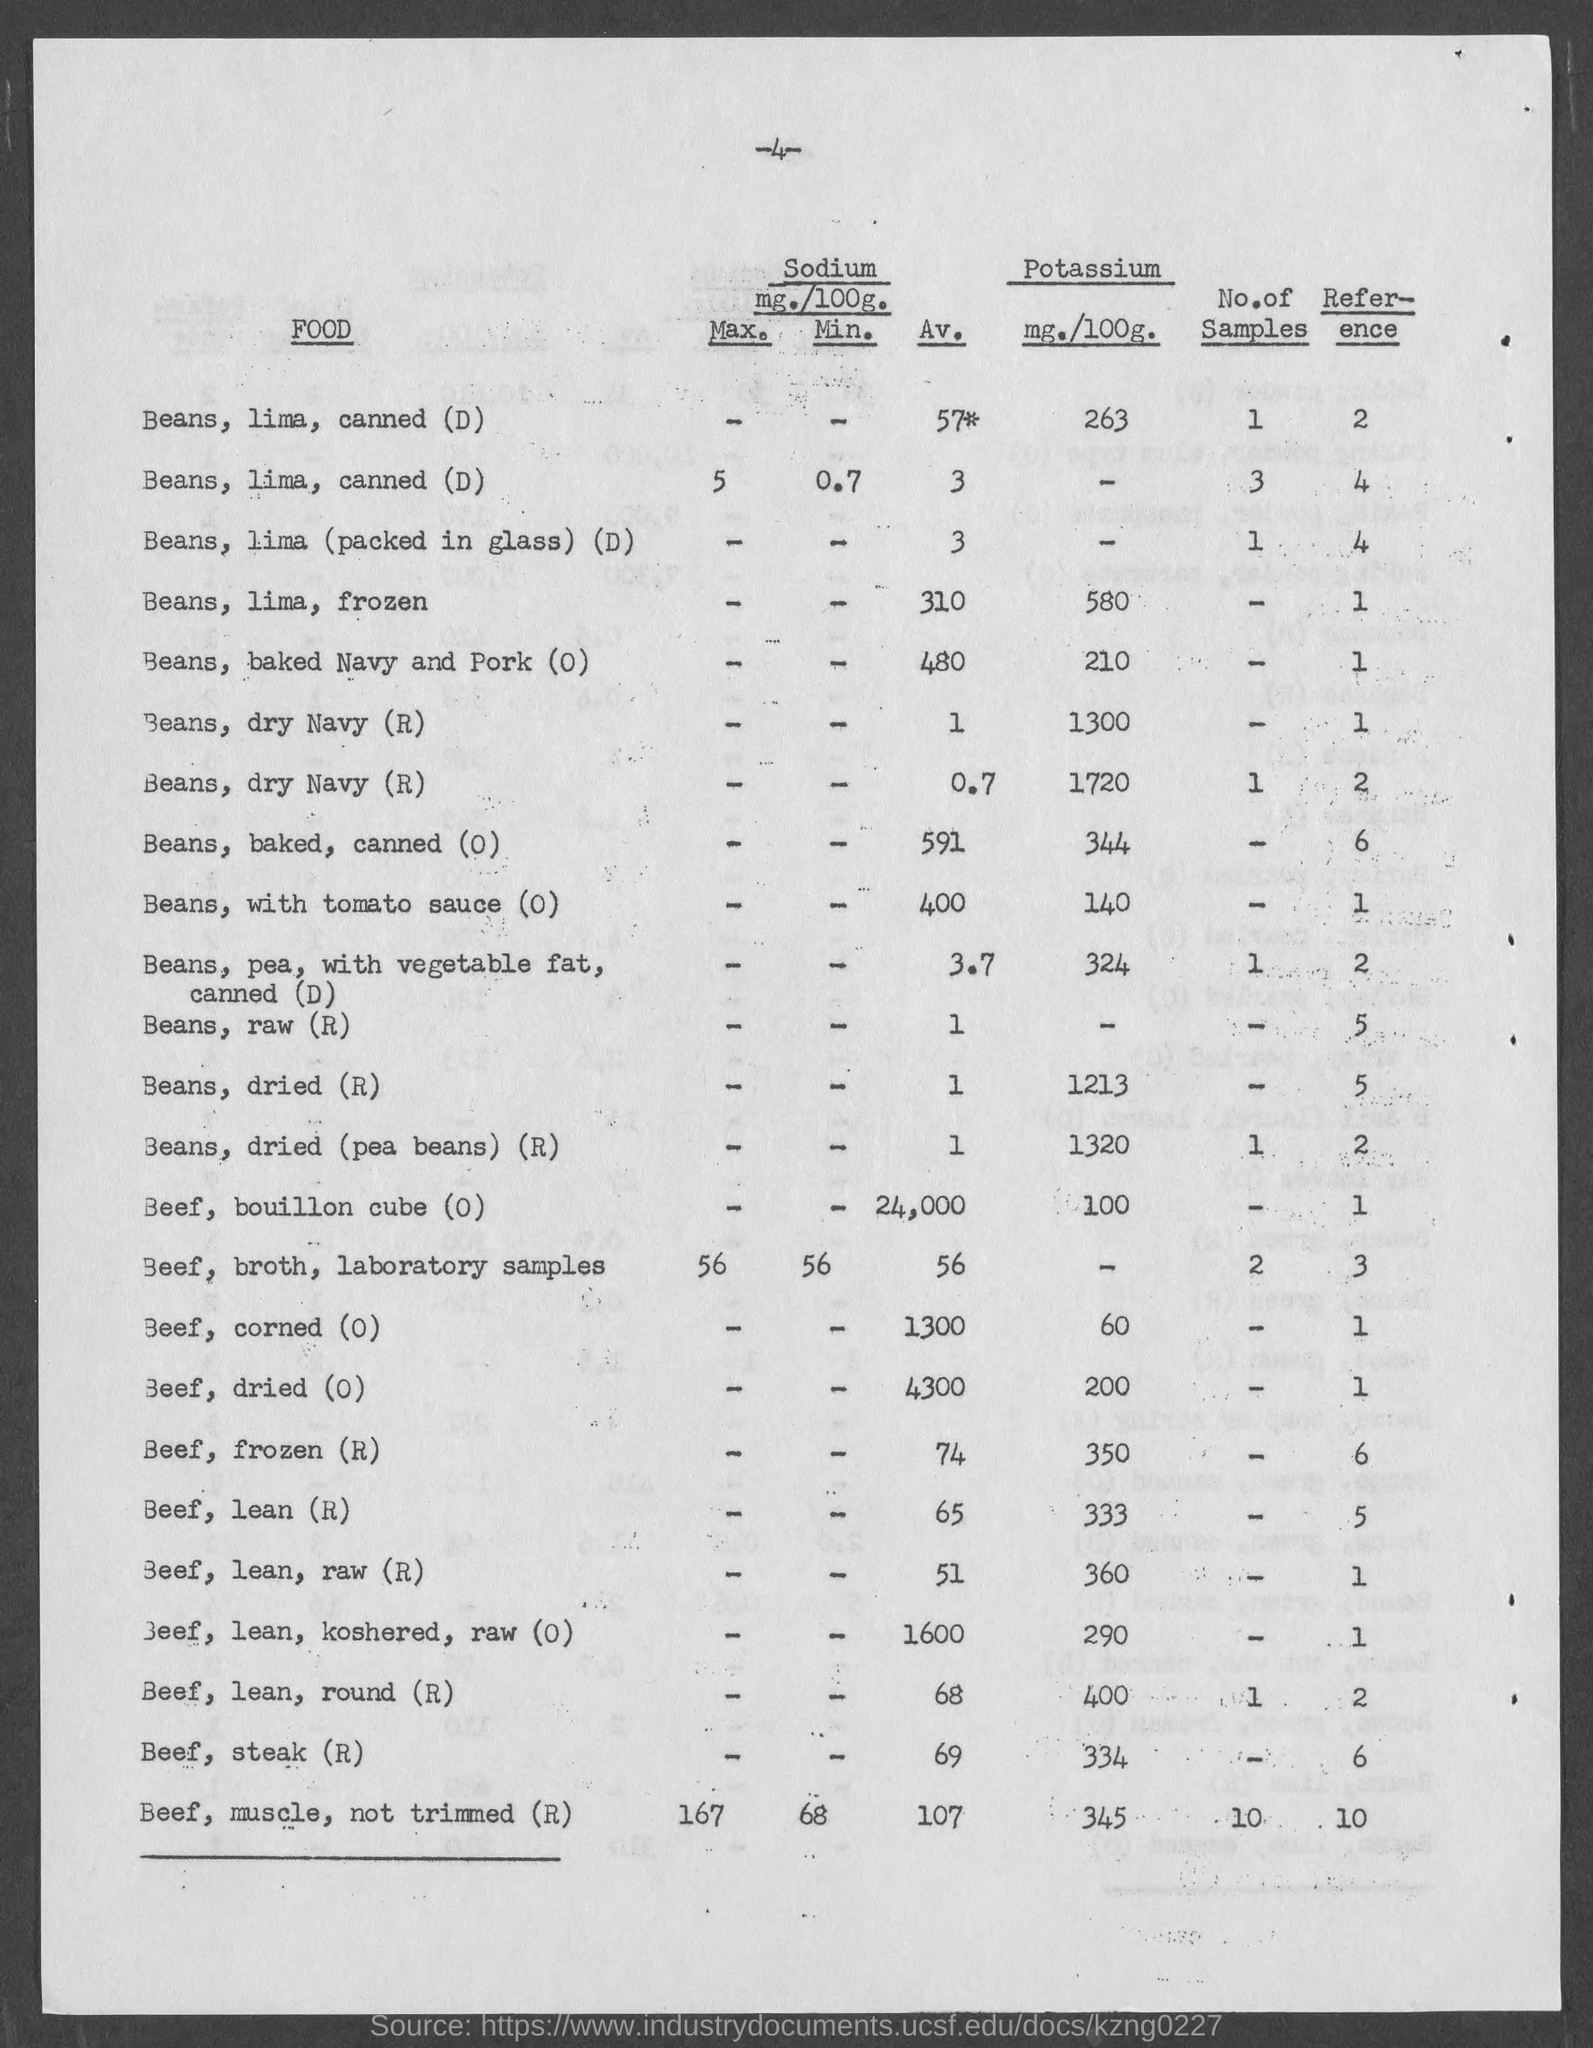Outline some significant characteristics in this image. The number at the top of the page is 4. 